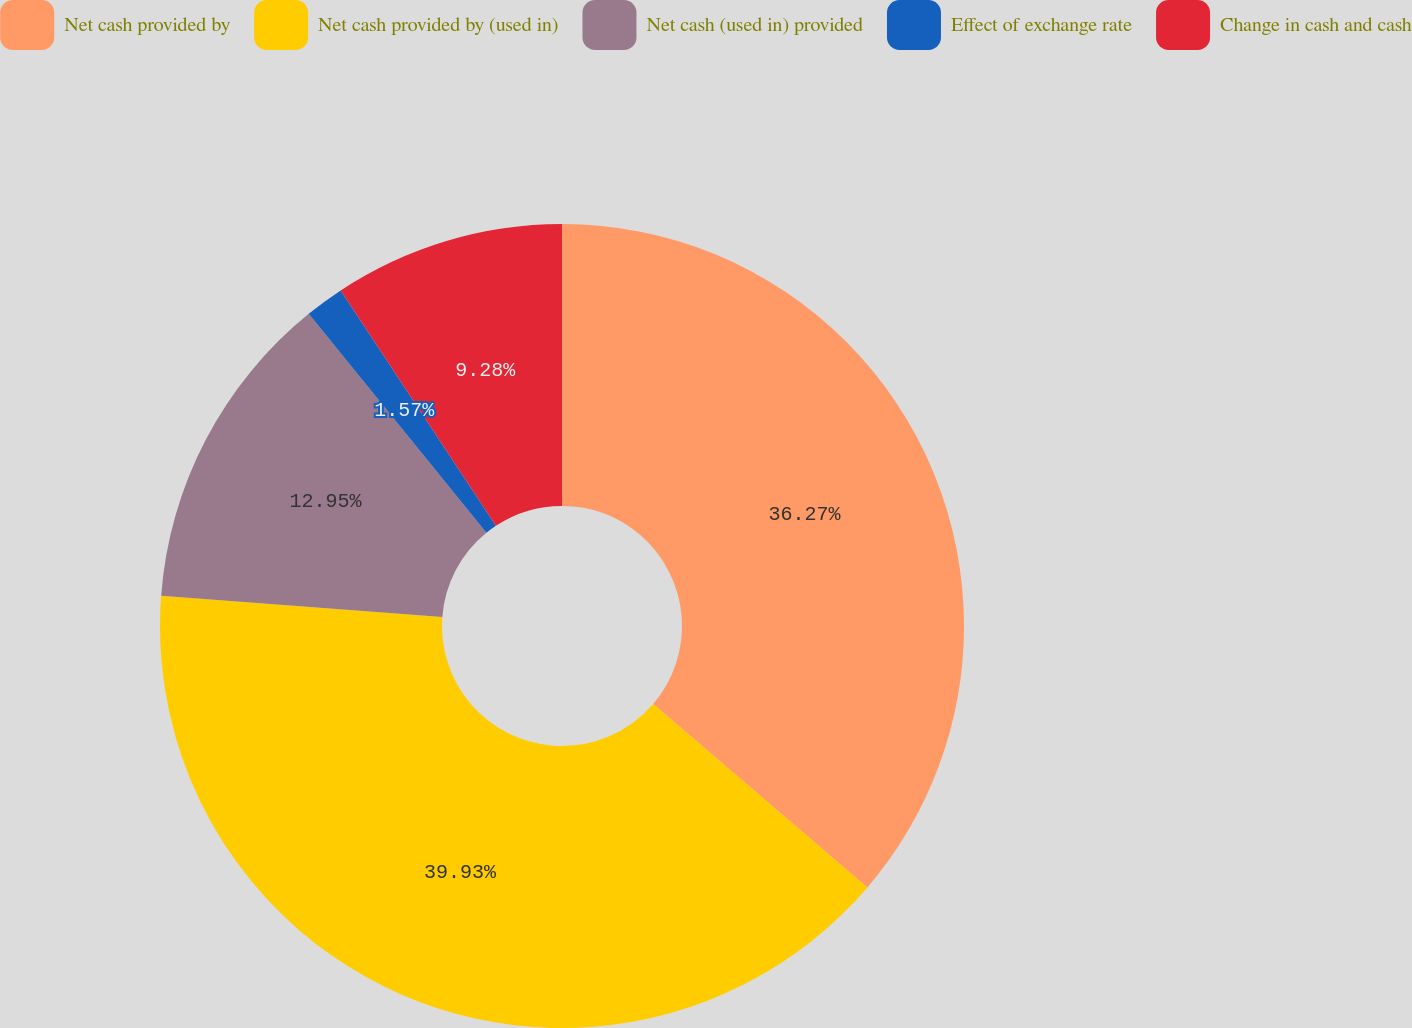Convert chart to OTSL. <chart><loc_0><loc_0><loc_500><loc_500><pie_chart><fcel>Net cash provided by<fcel>Net cash provided by (used in)<fcel>Net cash (used in) provided<fcel>Effect of exchange rate<fcel>Change in cash and cash<nl><fcel>36.27%<fcel>39.94%<fcel>12.95%<fcel>1.57%<fcel>9.28%<nl></chart> 